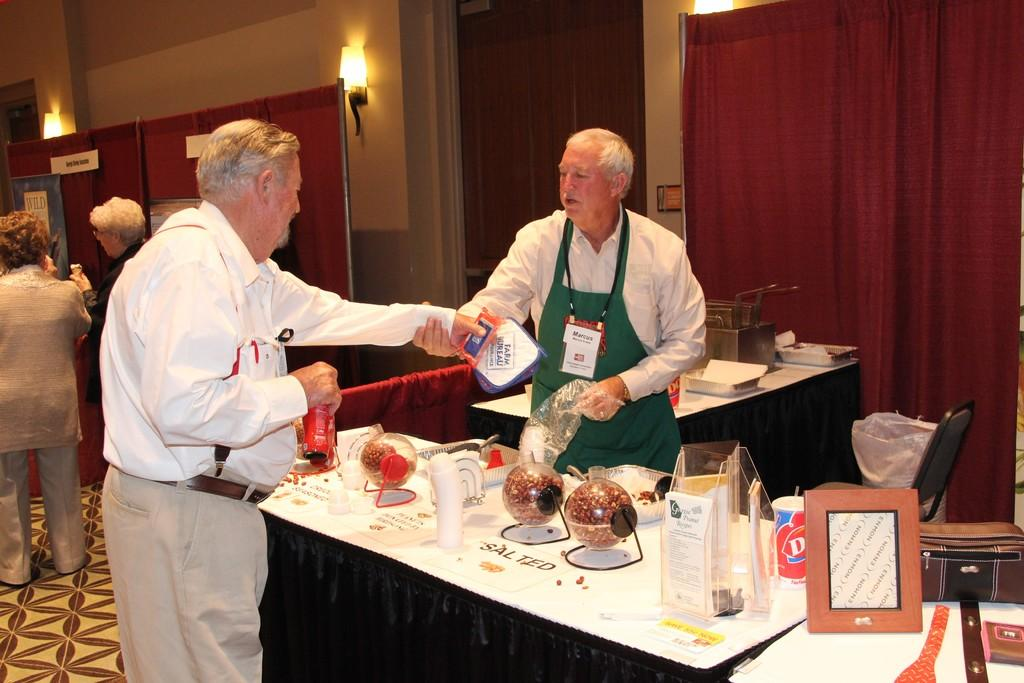How many people are standing in the image? There are two persons standing in the image. What is between the two persons? There is a table between the two persons. What can be found on the table? There is food on the table. What is hanging behind the persons? Curtains are hanging behind the persons. Where are the lights located in the image? There are lights on the wall. What type of throne can be seen in the image? There is no throne present in the image. Is there a cornfield visible in the image? There is no cornfield or corn visible in the image. 